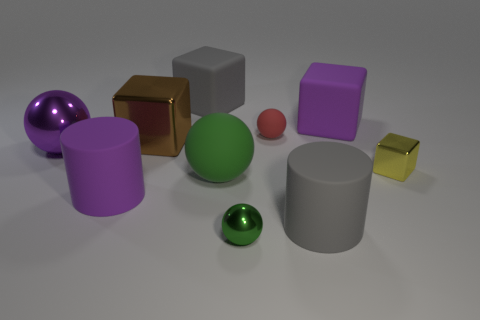Is the number of large metallic balls less than the number of tiny blue metal cubes?
Keep it short and to the point. No. Are the big purple cylinder and the green sphere that is right of the large rubber ball made of the same material?
Make the answer very short. No. There is a purple matte thing left of the small red object; what shape is it?
Your answer should be very brief. Cylinder. Are there any other things that are the same color as the large metal ball?
Provide a short and direct response. Yes. Is the number of metal objects behind the yellow shiny cube less than the number of small green objects?
Your response must be concise. No. What number of green matte objects are the same size as the purple rubber cylinder?
Your response must be concise. 1. The small metallic object that is the same color as the big matte sphere is what shape?
Provide a short and direct response. Sphere. What is the shape of the large gray object that is in front of the gray matte object that is left of the large gray object that is to the right of the red thing?
Keep it short and to the point. Cylinder. There is a metal ball that is in front of the big purple metallic ball; what is its color?
Your answer should be compact. Green. What number of objects are either large green objects in front of the large purple rubber cube or tiny green objects in front of the large gray cylinder?
Ensure brevity in your answer.  2. 